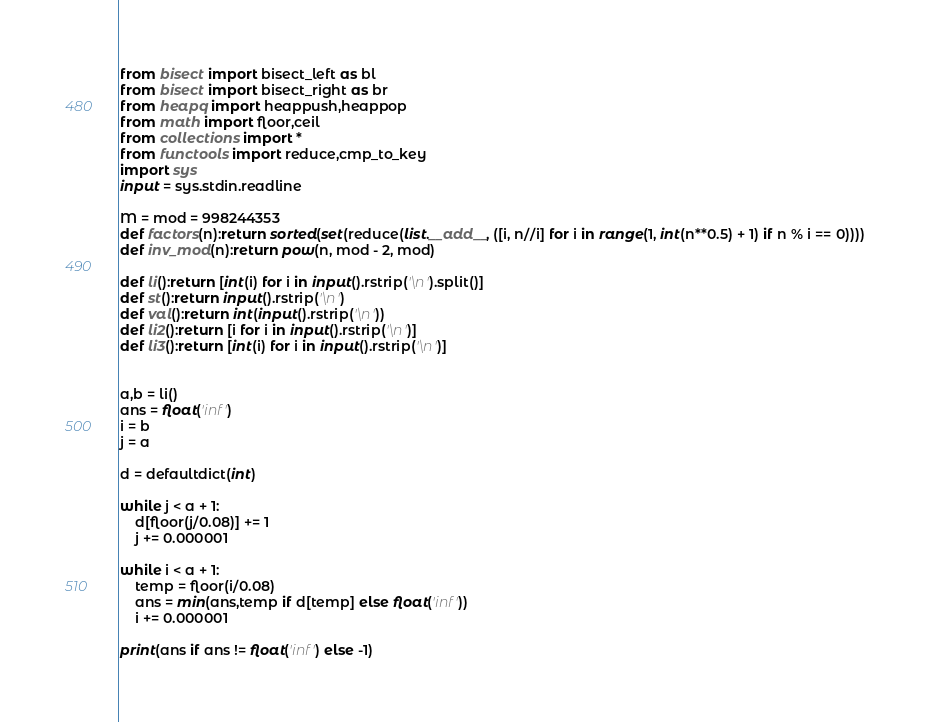<code> <loc_0><loc_0><loc_500><loc_500><_Python_>from bisect import bisect_left as bl
from bisect import bisect_right as br
from heapq import heappush,heappop
from math import floor,ceil
from collections import *
from functools import reduce,cmp_to_key
import sys
input = sys.stdin.readline

M = mod = 998244353
def factors(n):return sorted(set(reduce(list.__add__, ([i, n//i] for i in range(1, int(n**0.5) + 1) if n % i == 0))))
def inv_mod(n):return pow(n, mod - 2, mod)

def li():return [int(i) for i in input().rstrip('\n').split()]
def st():return input().rstrip('\n')
def val():return int(input().rstrip('\n'))
def li2():return [i for i in input().rstrip('\n')]
def li3():return [int(i) for i in input().rstrip('\n')]


a,b = li()
ans = float('inf')
i = b
j = a

d = defaultdict(int)

while j < a + 1:
    d[floor(j/0.08)] += 1
    j += 0.000001

while i < a + 1:
    temp = floor(i/0.08)
    ans = min(ans,temp if d[temp] else float('inf'))
    i += 0.000001

print(ans if ans != float('inf') else -1)


</code> 